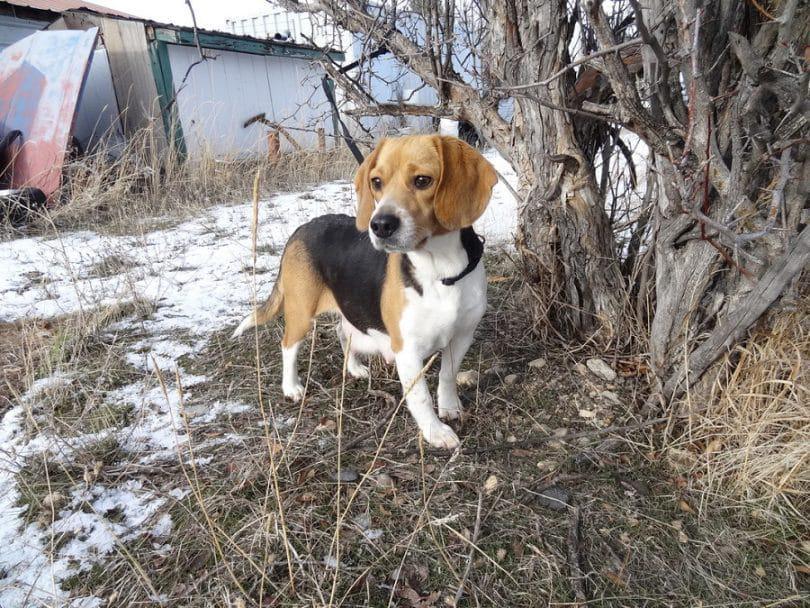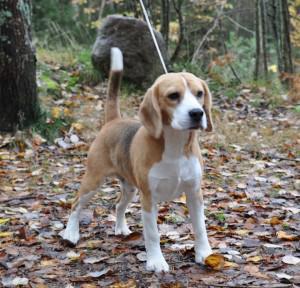The first image is the image on the left, the second image is the image on the right. Considering the images on both sides, is "Each image contains at least one beagle standing on all fours outdoors on the ground." valid? Answer yes or no. Yes. The first image is the image on the left, the second image is the image on the right. Evaluate the accuracy of this statement regarding the images: "There are exactly two dogs in total.". Is it true? Answer yes or no. Yes. 